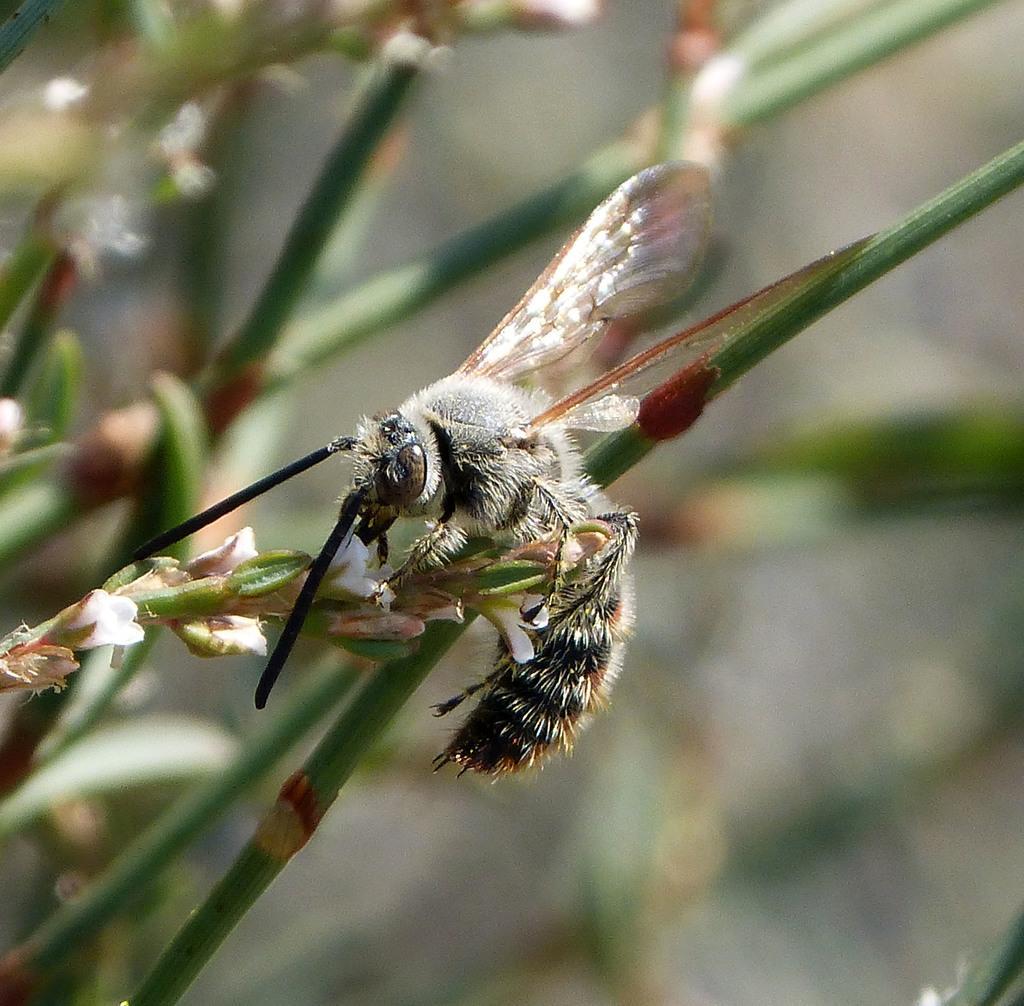In one or two sentences, can you explain what this image depicts? In this image there are few plants having flowers. An insect is on a plant. 